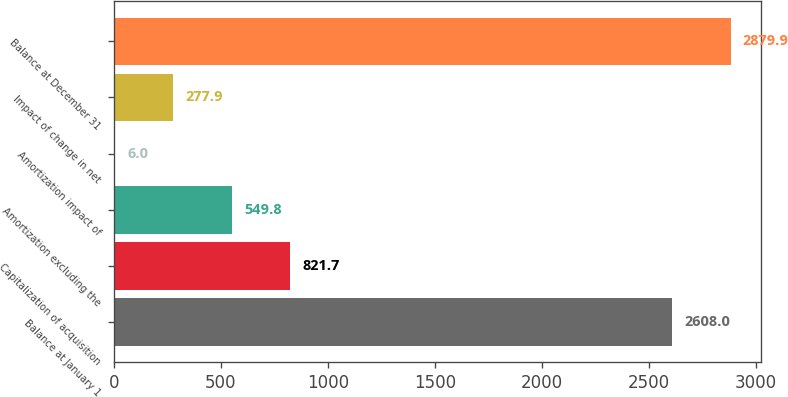Convert chart. <chart><loc_0><loc_0><loc_500><loc_500><bar_chart><fcel>Balance at January 1<fcel>Capitalization of acquisition<fcel>Amortization excluding the<fcel>Amortization impact of<fcel>Impact of change in net<fcel>Balance at December 31<nl><fcel>2608<fcel>821.7<fcel>549.8<fcel>6<fcel>277.9<fcel>2879.9<nl></chart> 